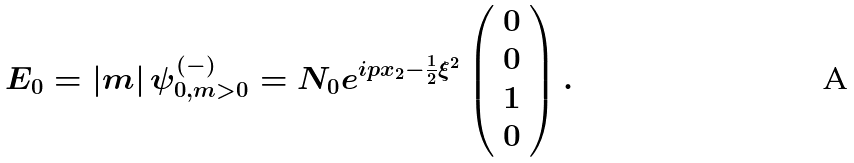Convert formula to latex. <formula><loc_0><loc_0><loc_500><loc_500>E _ { 0 } = | m | \, { \psi } _ { 0 , m > 0 } ^ { ( - ) } = N _ { 0 } e ^ { i p x _ { 2 } - \frac { 1 } { 2 } \xi ^ { 2 } } \left ( \begin{array} { c } 0 \\ 0 \\ 1 \\ 0 \end{array} \right ) .</formula> 